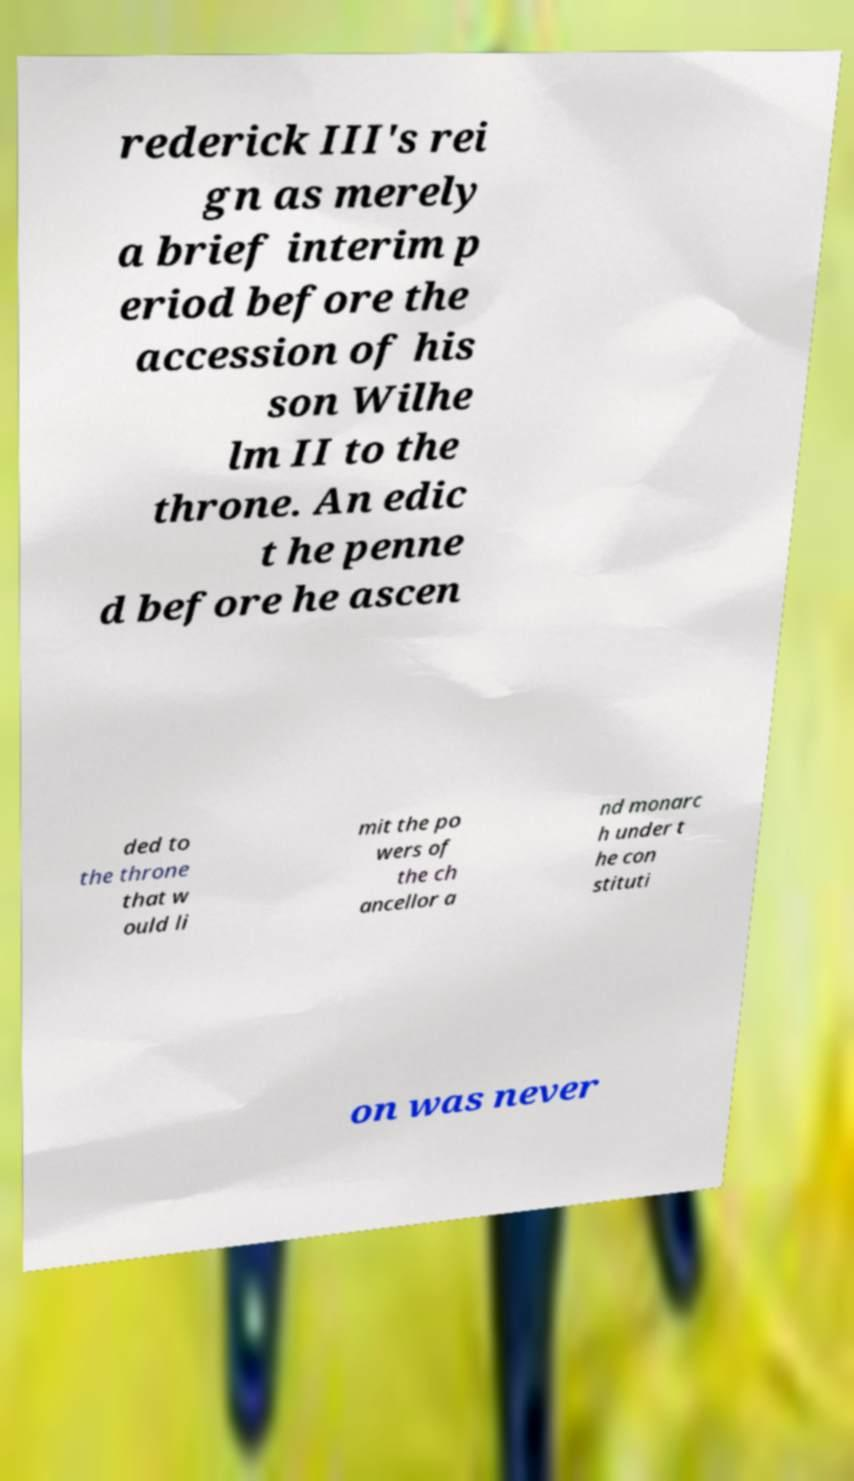Can you accurately transcribe the text from the provided image for me? rederick III's rei gn as merely a brief interim p eriod before the accession of his son Wilhe lm II to the throne. An edic t he penne d before he ascen ded to the throne that w ould li mit the po wers of the ch ancellor a nd monarc h under t he con stituti on was never 